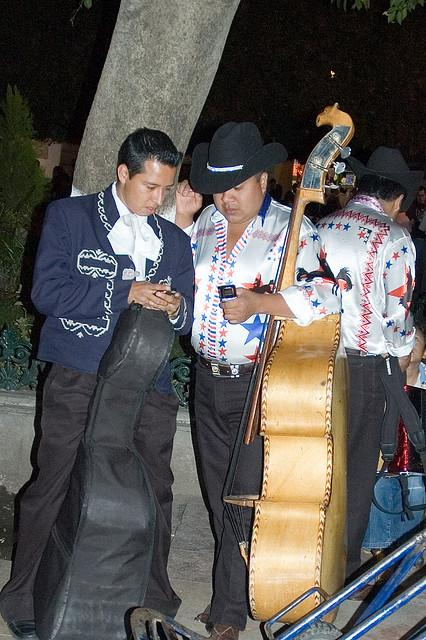What kind of music band do they play music in? Please explain your reasoning. mariachi. As indicated by their clothes, they're likely a. that said, they could be playing d music as well, as indicated by the guy's hat. 